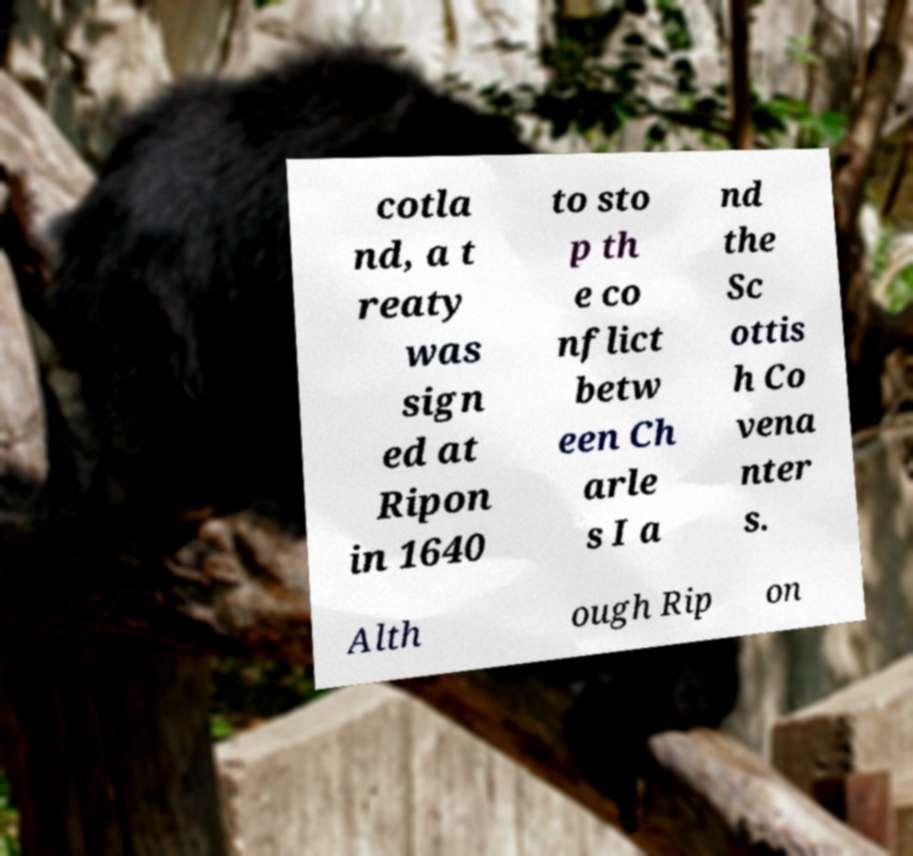Please identify and transcribe the text found in this image. cotla nd, a t reaty was sign ed at Ripon in 1640 to sto p th e co nflict betw een Ch arle s I a nd the Sc ottis h Co vena nter s. Alth ough Rip on 